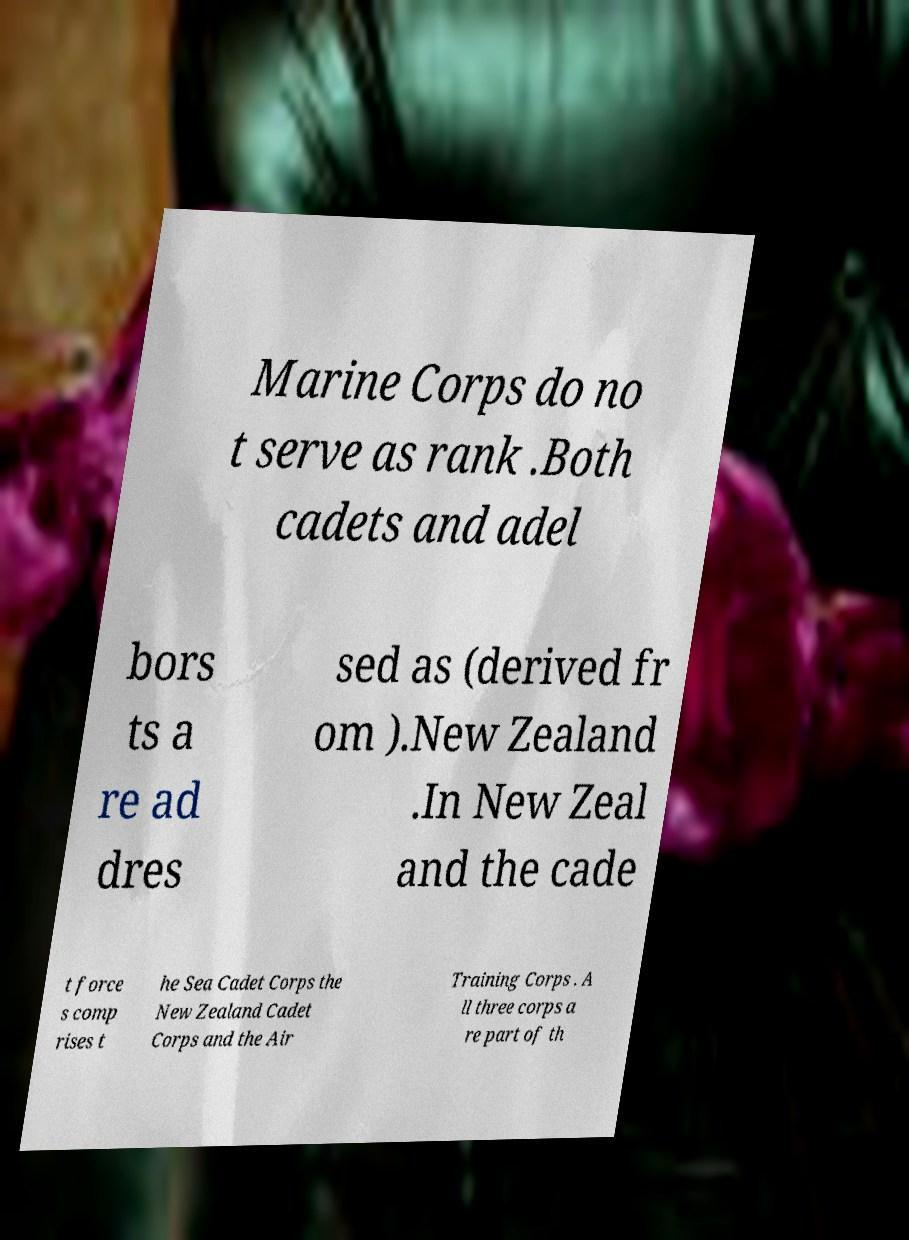Can you read and provide the text displayed in the image?This photo seems to have some interesting text. Can you extract and type it out for me? Marine Corps do no t serve as rank .Both cadets and adel bors ts a re ad dres sed as (derived fr om ).New Zealand .In New Zeal and the cade t force s comp rises t he Sea Cadet Corps the New Zealand Cadet Corps and the Air Training Corps . A ll three corps a re part of th 